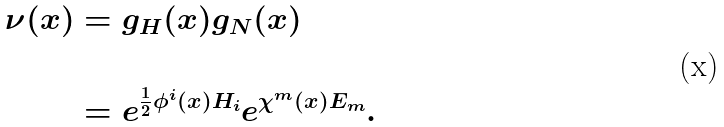<formula> <loc_0><loc_0><loc_500><loc_500>\nu ( x ) & = g _ { H } ( x ) g _ { N } ( x ) \\ \\ & = e ^ { \frac { 1 } { 2 } \phi ^ { i } ( x ) H _ { i } } e ^ { \chi ^ { m } ( x ) E _ { m } } .</formula> 